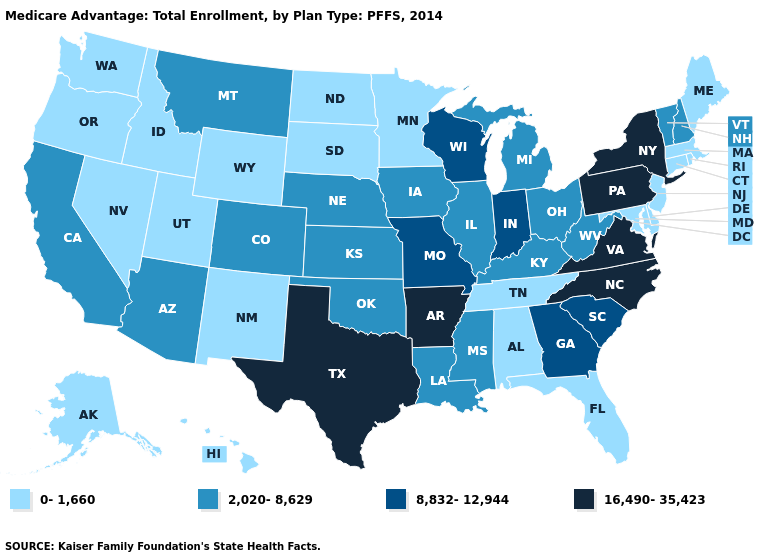What is the highest value in the South ?
Concise answer only. 16,490-35,423. Name the states that have a value in the range 0-1,660?
Write a very short answer. Alaska, Alabama, Connecticut, Delaware, Florida, Hawaii, Idaho, Massachusetts, Maryland, Maine, Minnesota, North Dakota, New Jersey, New Mexico, Nevada, Oregon, Rhode Island, South Dakota, Tennessee, Utah, Washington, Wyoming. What is the value of California?
Concise answer only. 2,020-8,629. What is the value of Vermont?
Concise answer only. 2,020-8,629. How many symbols are there in the legend?
Short answer required. 4. Among the states that border New Mexico , does Utah have the lowest value?
Give a very brief answer. Yes. Among the states that border Colorado , does New Mexico have the lowest value?
Concise answer only. Yes. Does North Dakota have the lowest value in the MidWest?
Write a very short answer. Yes. What is the lowest value in the South?
Answer briefly. 0-1,660. How many symbols are there in the legend?
Answer briefly. 4. What is the value of Arkansas?
Answer briefly. 16,490-35,423. Among the states that border Nevada , does Utah have the highest value?
Quick response, please. No. Name the states that have a value in the range 0-1,660?
Concise answer only. Alaska, Alabama, Connecticut, Delaware, Florida, Hawaii, Idaho, Massachusetts, Maryland, Maine, Minnesota, North Dakota, New Jersey, New Mexico, Nevada, Oregon, Rhode Island, South Dakota, Tennessee, Utah, Washington, Wyoming. Does Illinois have the highest value in the USA?
Be succinct. No. Among the states that border Massachusetts , does New Hampshire have the lowest value?
Write a very short answer. No. 